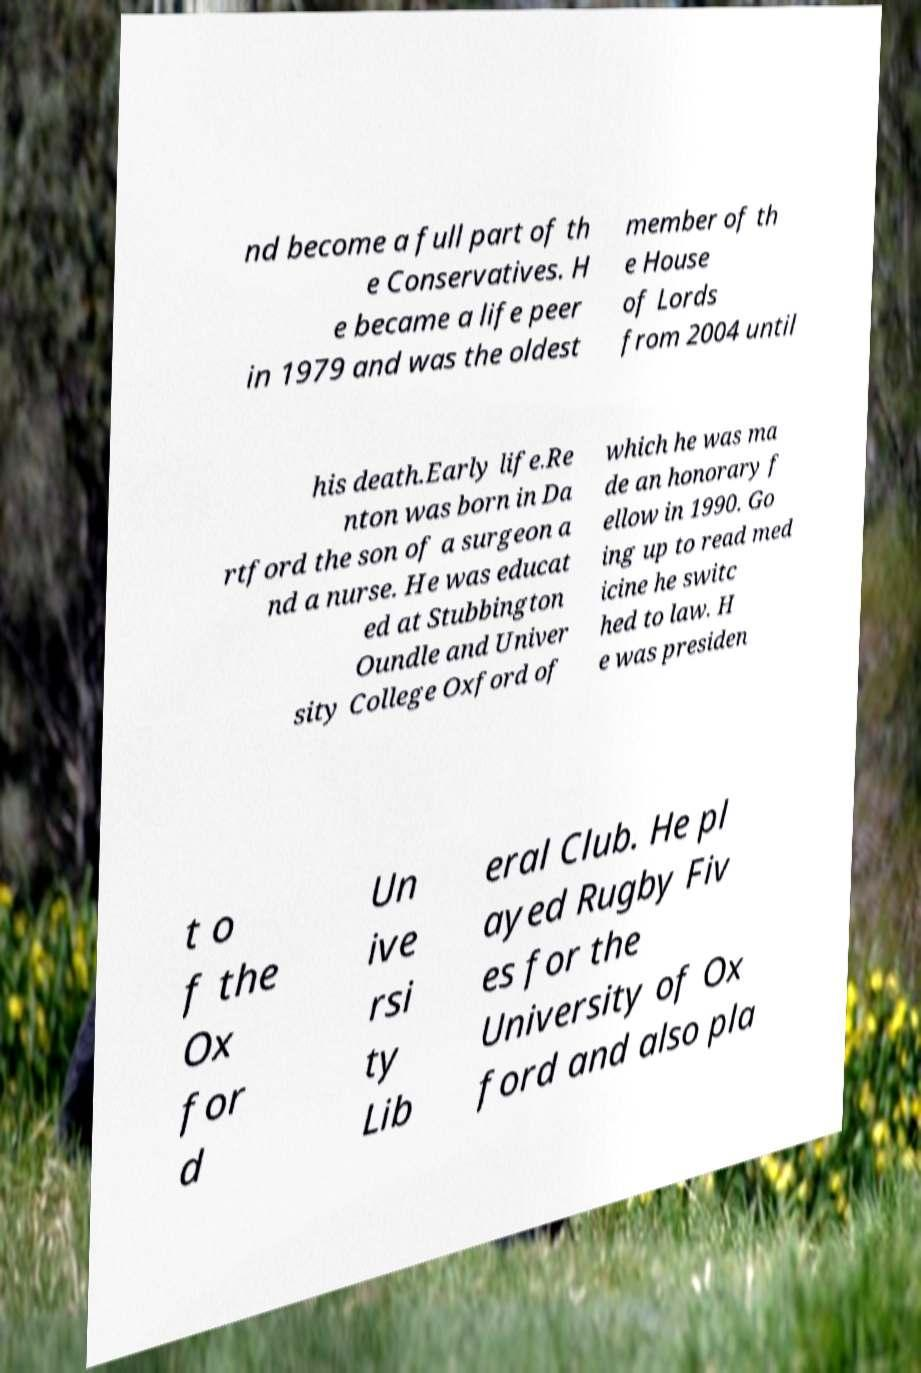Could you extract and type out the text from this image? nd become a full part of th e Conservatives. H e became a life peer in 1979 and was the oldest member of th e House of Lords from 2004 until his death.Early life.Re nton was born in Da rtford the son of a surgeon a nd a nurse. He was educat ed at Stubbington Oundle and Univer sity College Oxford of which he was ma de an honorary f ellow in 1990. Go ing up to read med icine he switc hed to law. H e was presiden t o f the Ox for d Un ive rsi ty Lib eral Club. He pl ayed Rugby Fiv es for the University of Ox ford and also pla 